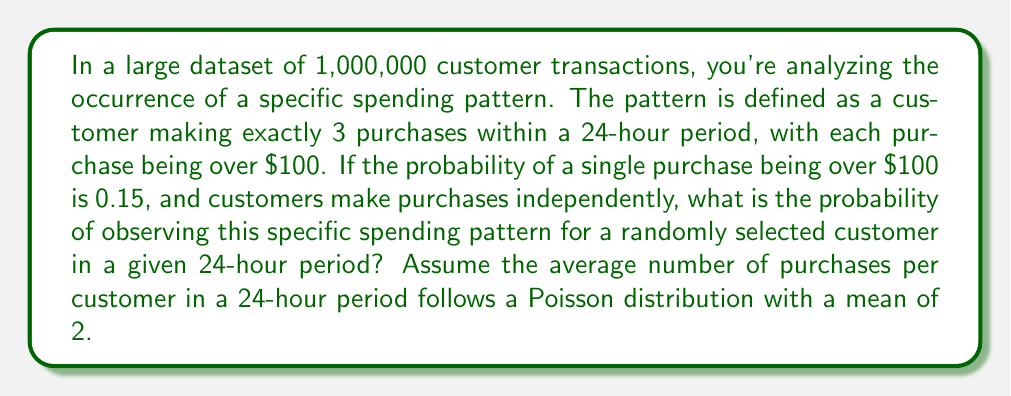Can you solve this math problem? To solve this problem, we'll follow these steps:

1) First, we need to calculate the probability of making exactly 3 purchases in a 24-hour period. This follows a Poisson distribution with λ = 2.

   $P(X = 3) = \frac{e^{-λ}λ^k}{k!} = \frac{e^{-2}2^3}{3!} = \frac{4e^{-2}}{3}$

2) Next, we need to calculate the probability that all 3 purchases are over $100. Since each purchase is independent and has a 0.15 probability of being over $100:

   $P(\text{all 3 over } \$100) = 0.15^3 = 0.003375$

3) The probability we're looking for is the product of these two probabilities:

   $P(\text{3 purchases AND all over } \$100) = \frac{4e^{-2}}{3} \times 0.003375$

4) Let's calculate this:

   $\frac{4e^{-2}}{3} \approx 0.1804470443$
   
   $0.1804470443 \times 0.003375 \approx 0.0006090087$

Therefore, the probability of observing this specific spending pattern for a randomly selected customer in a given 24-hour period is approximately 0.0006090087 or about 0.06%.
Answer: $\frac{4e^{-2}}{3} \times 0.15^3 \approx 0.0006090087$ 